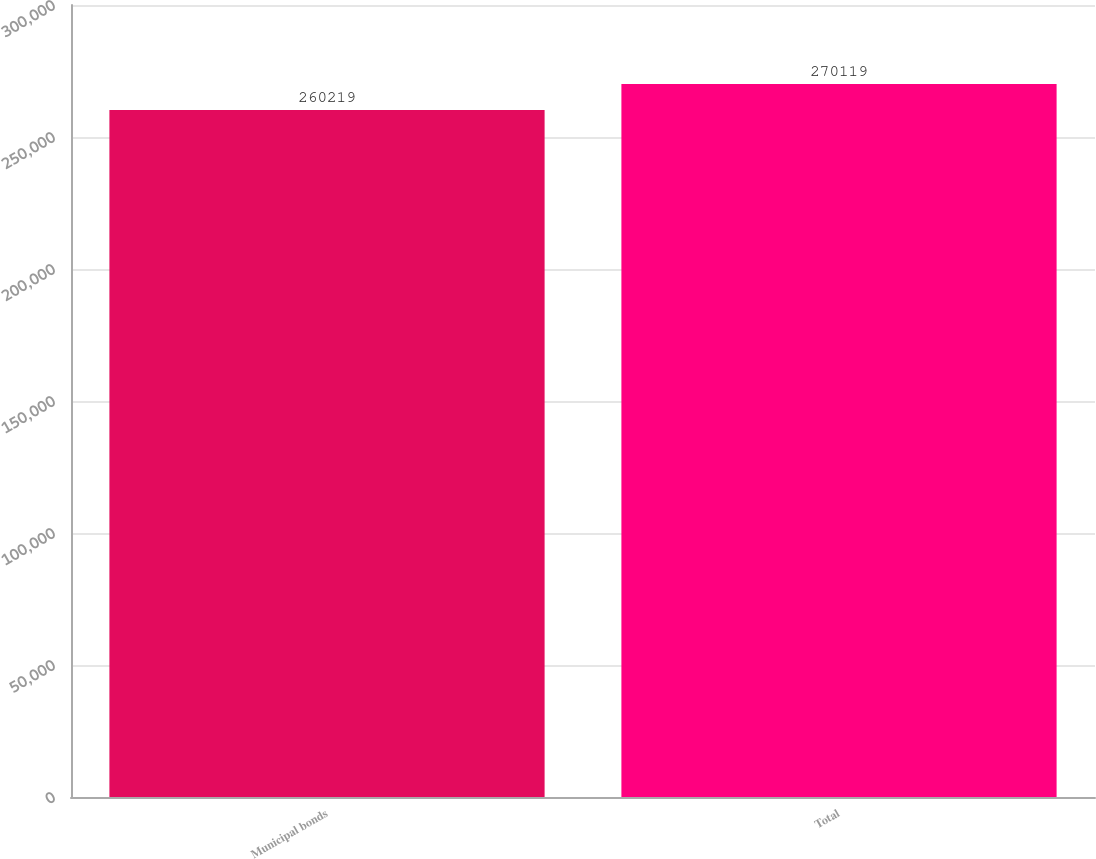Convert chart. <chart><loc_0><loc_0><loc_500><loc_500><bar_chart><fcel>Municipal bonds<fcel>Total<nl><fcel>260219<fcel>270119<nl></chart> 